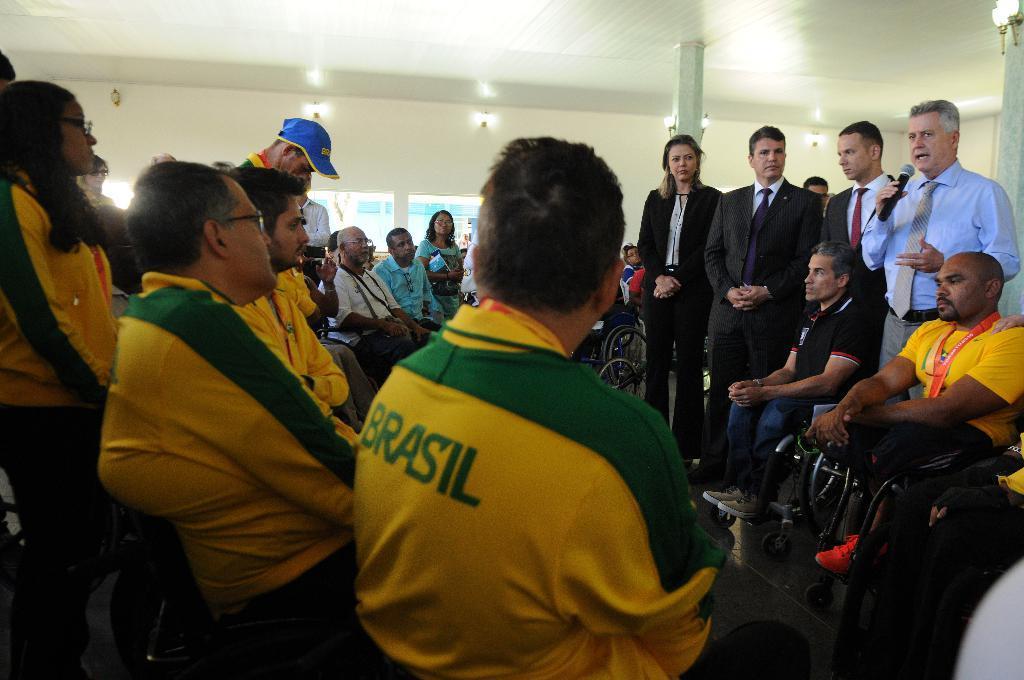Describe this image in one or two sentences. In this image I can see the group of people with different color dresses. I can see few people are wearing the green and yellow color dresses. I can see few people are sitting on the wheel chairs and few people are standing. One person is holding the mic and one person is wearing the cap. In the background I can see the window and lights in the top. 